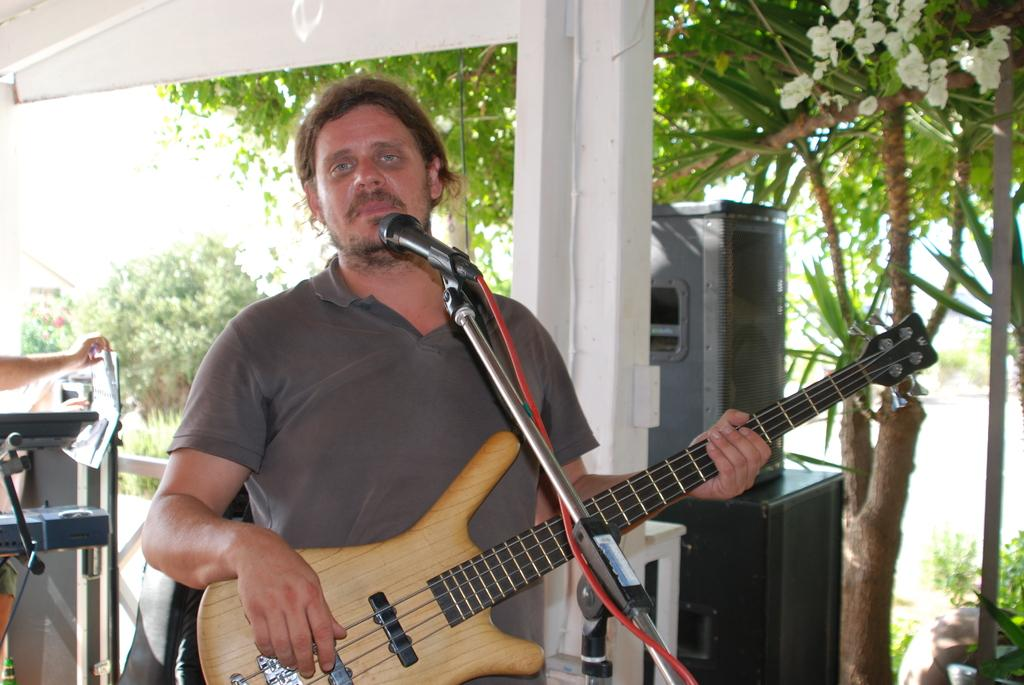What is the man in the image doing? The man is standing and holding a guitar. What is the man near in the image? The man is near a microphone. What can be seen in the background of the image? There are sound boxes, trees, plants, and musical instruments in the background of the image. What type of badge is the actor wearing in the image? There is no actor or badge present in the image. What is the coil used for in the image? There is no coil present in the image. 